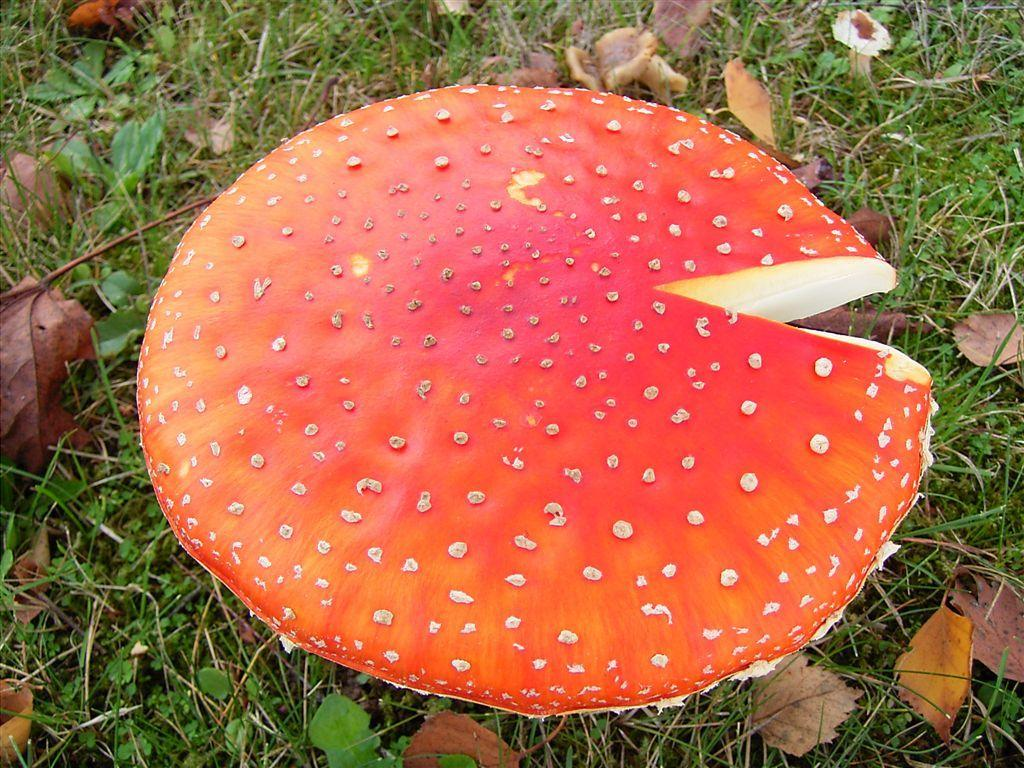What type of surface is visible in the image? There is a grass surface in the image. What can be seen growing on the grass surface? Plant saplings and dried leaves are present on the grass surface. What type of fungus is visible in the image? There is a mushroom in the image. Can you describe the color and appearance of the mushroom? The mushroom is dark orange in color with some yellow coloring and spots on it. How many dimes are scattered on the grass surface in the image? There are no dimes present in the image; it features a grass surface with plant saplings, dried leaves, and a mushroom. What type of wrist accessory is visible on the mushroom in the image? There are no wrist accessories present in the image; it features a grass surface with plant saplings, dried leaves, and a mushroom. 